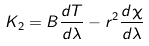<formula> <loc_0><loc_0><loc_500><loc_500>K _ { 2 } = B \frac { d T } { d \lambda } - r ^ { 2 } \frac { d \chi } { d \lambda }</formula> 